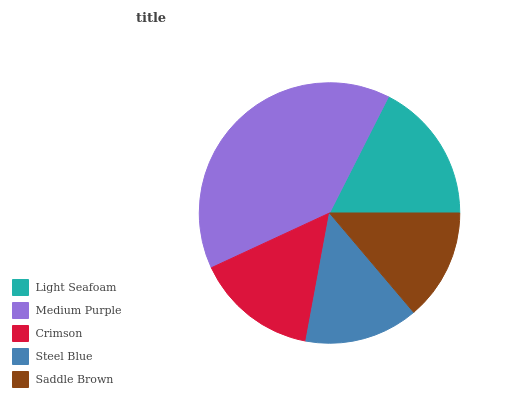Is Saddle Brown the minimum?
Answer yes or no. Yes. Is Medium Purple the maximum?
Answer yes or no. Yes. Is Crimson the minimum?
Answer yes or no. No. Is Crimson the maximum?
Answer yes or no. No. Is Medium Purple greater than Crimson?
Answer yes or no. Yes. Is Crimson less than Medium Purple?
Answer yes or no. Yes. Is Crimson greater than Medium Purple?
Answer yes or no. No. Is Medium Purple less than Crimson?
Answer yes or no. No. Is Crimson the high median?
Answer yes or no. Yes. Is Crimson the low median?
Answer yes or no. Yes. Is Medium Purple the high median?
Answer yes or no. No. Is Light Seafoam the low median?
Answer yes or no. No. 